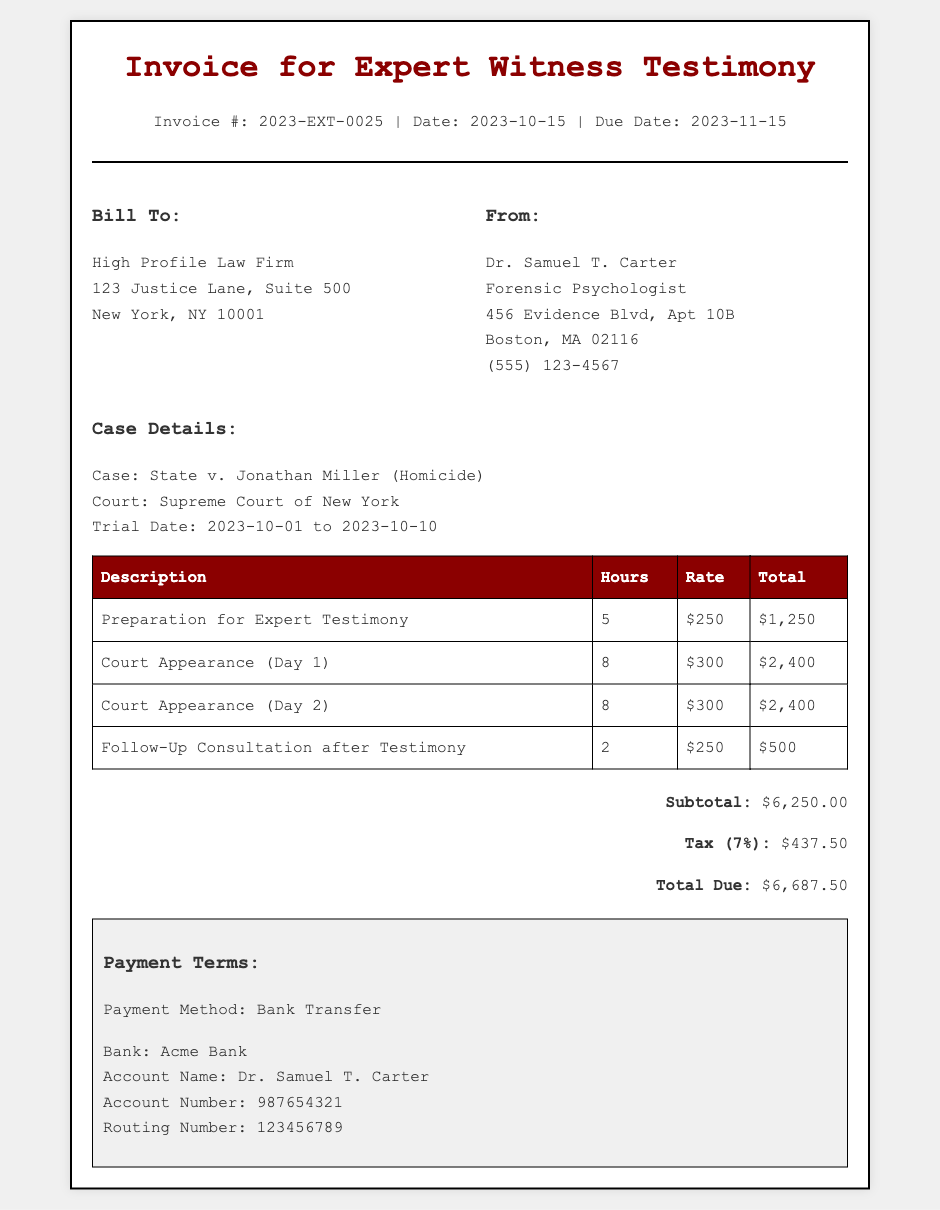What is the invoice number? The invoice number is listed at the top of the invoice for reference.
Answer: 2023-EXT-0025 Who is the expert witness? The document specifies the professional who provided testimony in the case.
Answer: Dr. Samuel T. Carter What is the total due amount? The total due amount is calculated at the end of the invoice, after adding the subtotal and tax.
Answer: $6,687.50 What is the hourly rate for court appearances? The document specifies the rate charged by the expert witness for court appearances.
Answer: $300 How many hours were worked for preparation for expert testimony? The bill breaks down hours for specific tasks and shows the number for preparation.
Answer: 5 What is the tax rate applied to the invoice? The tax rate for the services rendered is specified in the summary section of the invoice.
Answer: 7% What is the total amount charged for court appearance on Day 1? The invoice breaks down charges for each service, providing the total amount for the first court appearance.
Answer: $2,400 What payment method is specified in the document? The payment terms section of the invoice details how the payment should be made.
Answer: Bank Transfer What is the due date for payment? The invoice includes payment terms that clearly state when the payment is due.
Answer: 2023-11-15 